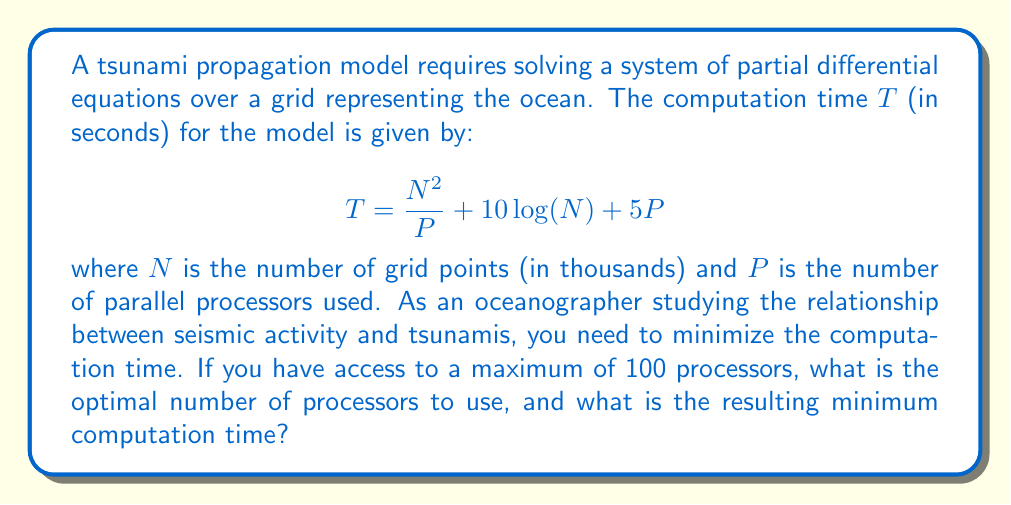Give your solution to this math problem. To solve this optimization problem, we need to find the minimum value of $T$ with respect to $P$, subject to the constraint that $P \leq 100$.

1) First, let's differentiate $T$ with respect to $P$:

   $$\frac{dT}{dP} = -\frac{N^2}{P^2} + 5$$

2) Set this derivative to zero to find the critical point:

   $$-\frac{N^2}{P^2} + 5 = 0$$
   $$\frac{N^2}{P^2} = 5$$
   $$P^2 = \frac{N^2}{5}$$
   $$P = \frac{N}{\sqrt{5}}$$

3) This critical point gives us the optimal number of processors. However, we need to check if this value is within our constraint of $P \leq 100$.

4) The largest value of $N$ that satisfies our constraint is when:

   $$\frac{N}{\sqrt{5}} = 100$$
   $$N = 100\sqrt{5} \approx 223.6$$

5) Since $N$ is given in thousands of grid points, this corresponds to about 223,600 grid points.

6) For any $N > 100\sqrt{5}$, the optimal $P$ would be 100 (our maximum allowed value).
   For any $N < 100\sqrt{5}$, the optimal $P$ would be $\frac{N}{\sqrt{5}}$.

7) To find the minimum computation time, we substitute these optimal $P$ values back into our original equation:

   For $N \leq 100\sqrt{5}$: 
   $$T_{min} = \frac{N^2}{\frac{N}{\sqrt{5}}} + 10\log(N) + 5\frac{N}{\sqrt{5}}$$
   $$T_{min} = N\sqrt{5} + 10\log(N) + 5\frac{N}{\sqrt{5}}$$

   For $N > 100\sqrt{5}$:
   $$T_{min} = \frac{N^2}{100} + 10\log(N) + 500$$

8) The exact minimum time and optimal number of processors will depend on the specific value of $N$ used in the model.
Answer: The optimal number of processors $P$ is given by:

$$P = \min\left(\frac{N}{\sqrt{5}}, 100\right)$$

The minimum computation time $T_{min}$ is:

$$T_{min} = \begin{cases}
N\sqrt{5} + 10\log(N) + 5\frac{N}{\sqrt{5}} & \text{if } N \leq 100\sqrt{5} \\
\frac{N^2}{100} + 10\log(N) + 500 & \text{if } N > 100\sqrt{5}
\end{cases}$$

where $N$ is the number of grid points in thousands. 